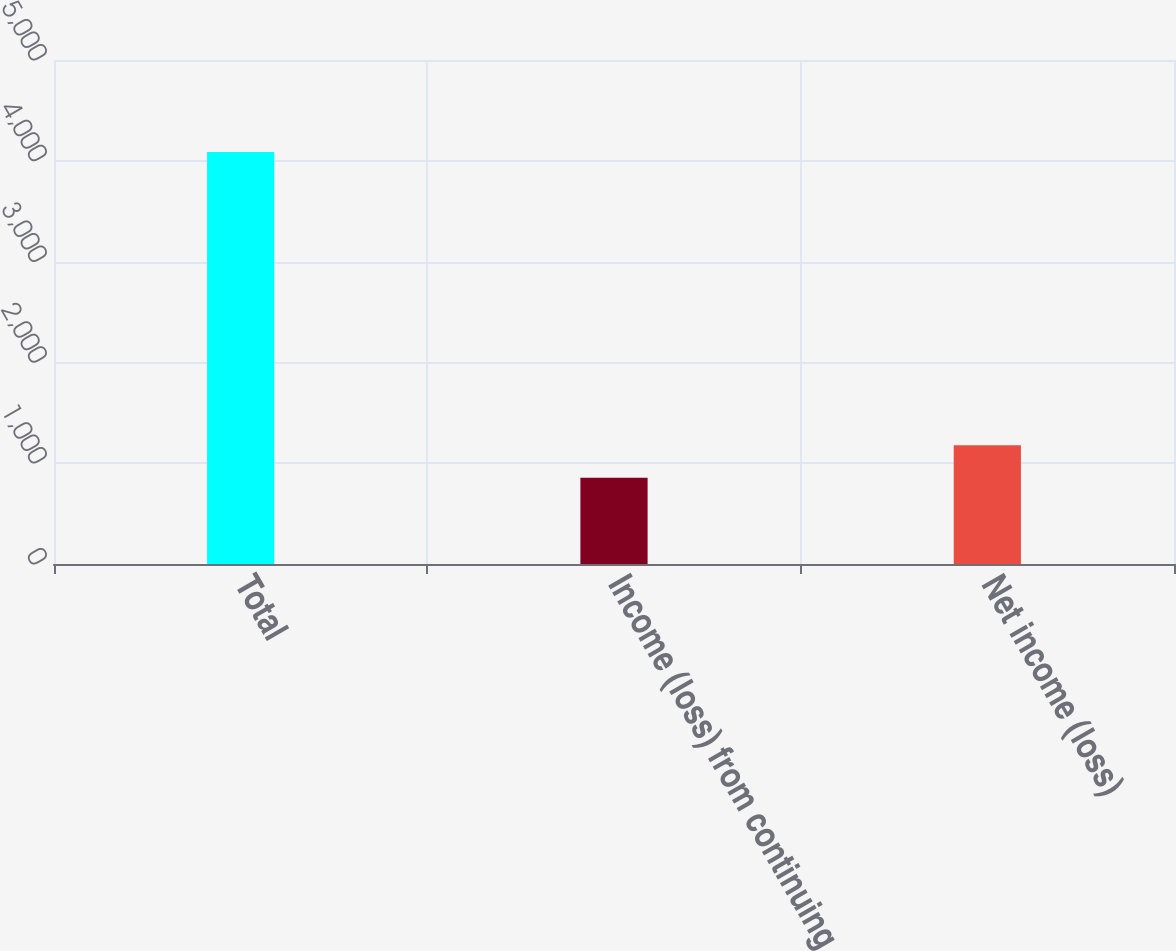Convert chart to OTSL. <chart><loc_0><loc_0><loc_500><loc_500><bar_chart><fcel>Total<fcel>Income (loss) from continuing<fcel>Net income (loss)<nl><fcel>4087<fcel>855<fcel>1178.2<nl></chart> 